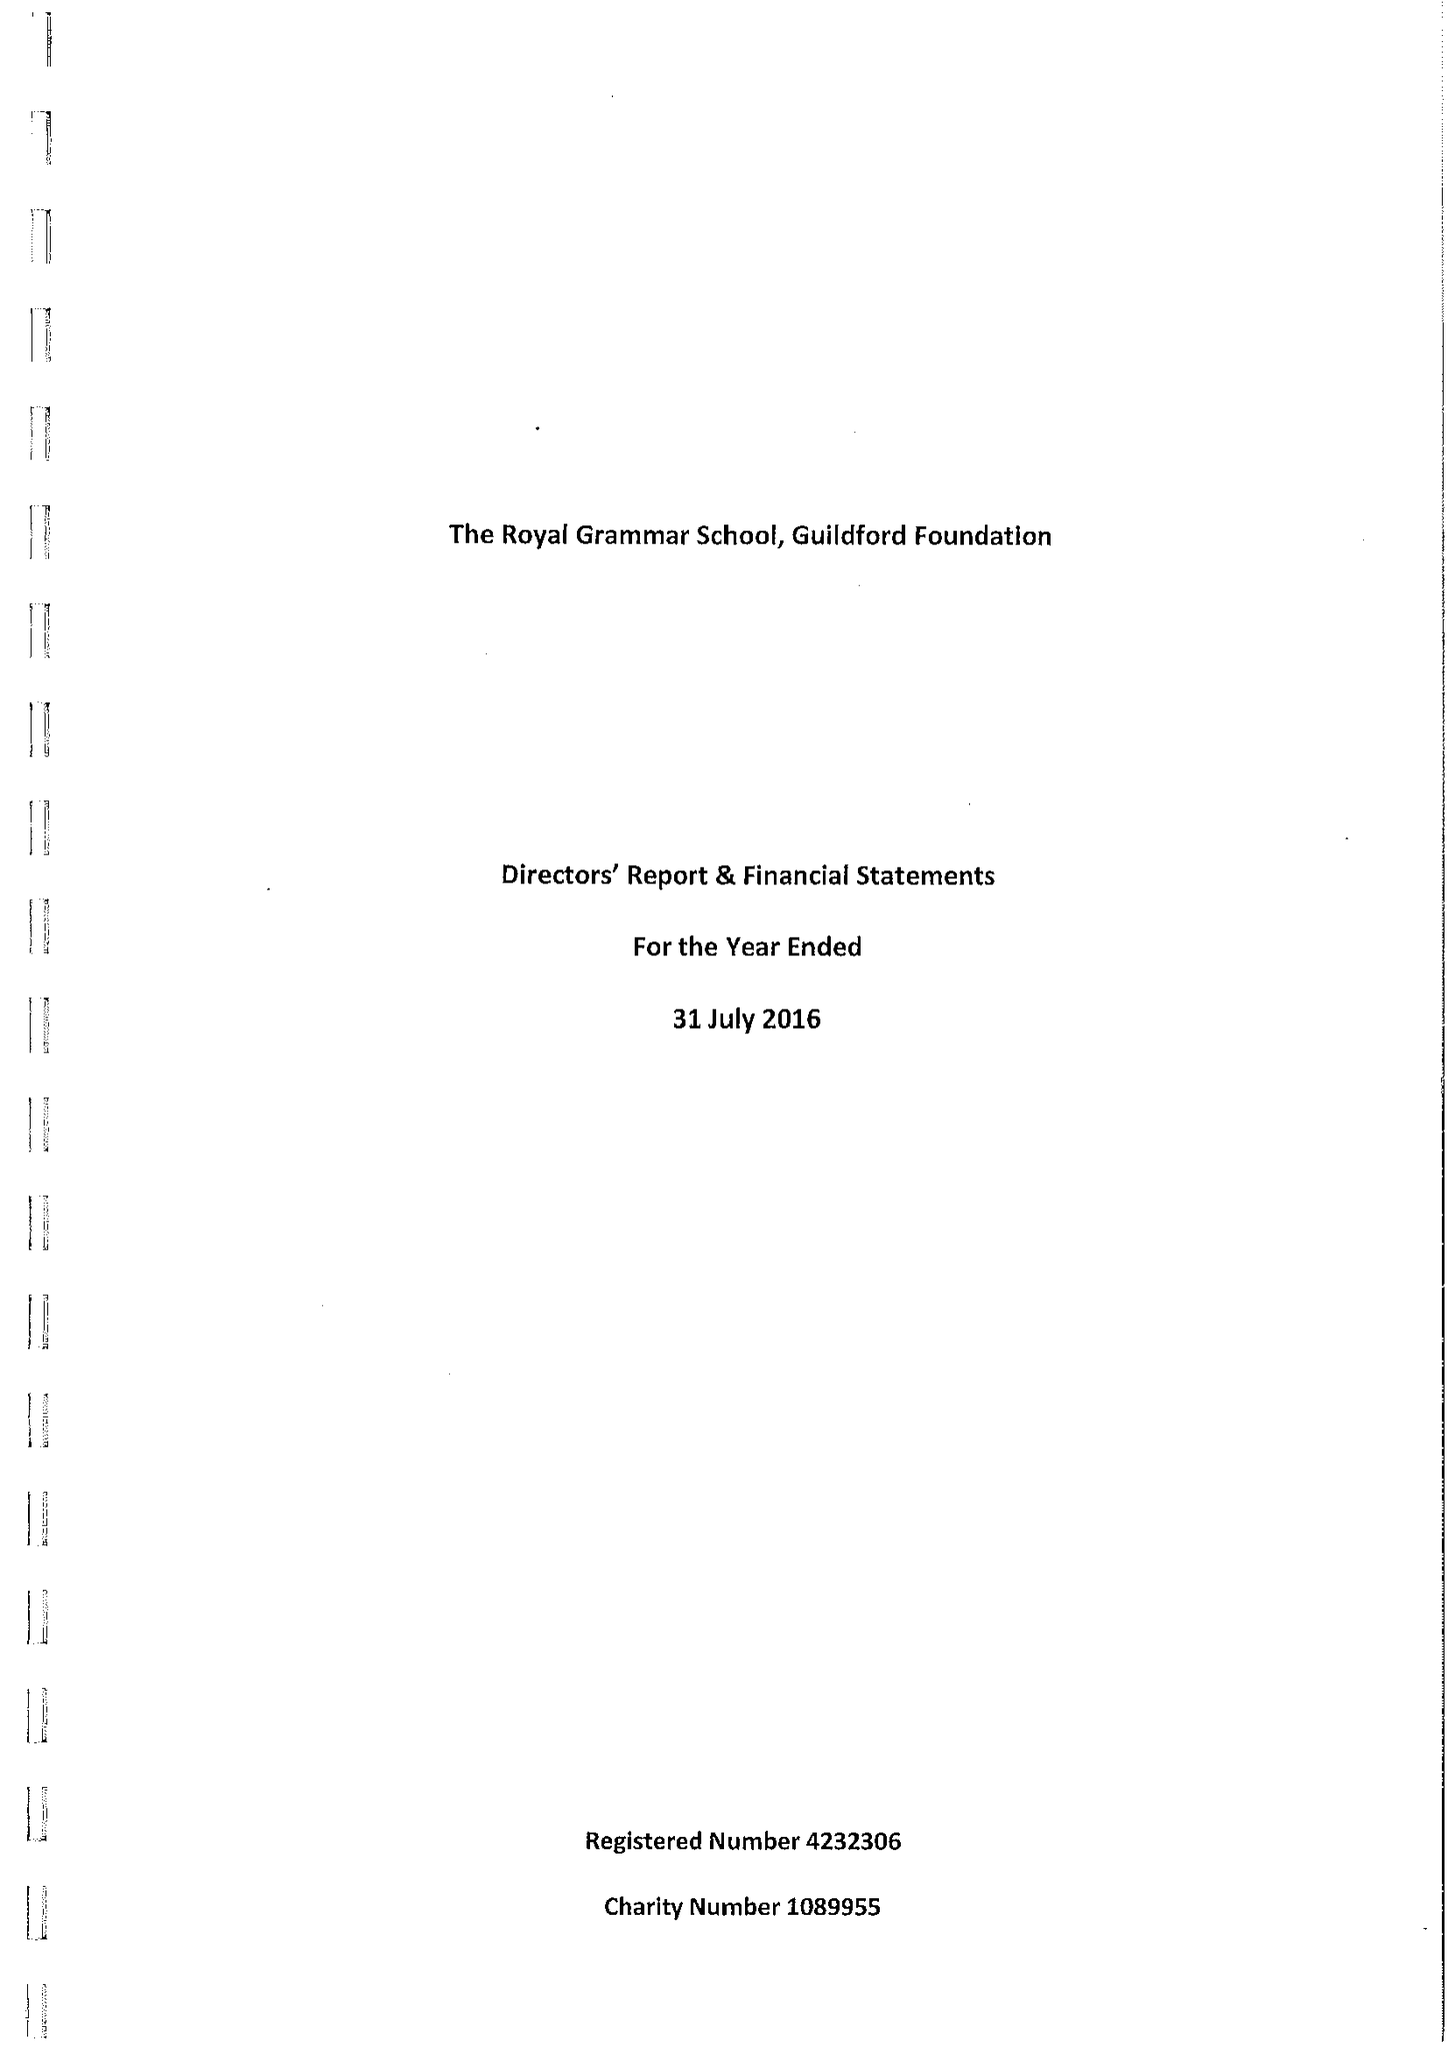What is the value for the address__postcode?
Answer the question using a single word or phrase. GU1 3BB 